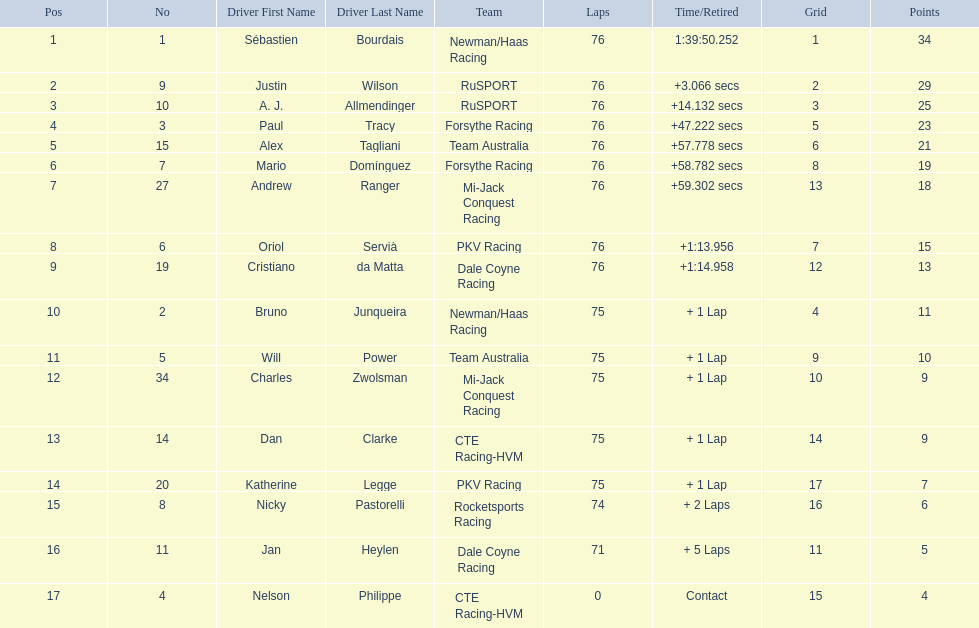What was alex taglini's final score in the tecate grand prix? 21. What was paul tracy's final score in the tecate grand prix? 23. Which driver finished first? Paul Tracy. 